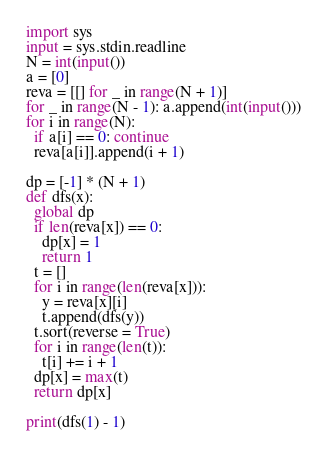Convert code to text. <code><loc_0><loc_0><loc_500><loc_500><_Python_>import sys
input = sys.stdin.readline
N = int(input())
a = [0]
reva = [[] for _ in range(N + 1)]
for _ in range(N - 1): a.append(int(input()))
for i in range(N):
  if a[i] == 0: continue
  reva[a[i]].append(i + 1)

dp = [-1] * (N + 1)
def dfs(x):
  global dp
  if len(reva[x]) == 0:
    dp[x] = 1
    return 1
  t = []
  for i in range(len(reva[x])):
    y = reva[x][i]
    t.append(dfs(y))
  t.sort(reverse = True)
  for i in range(len(t)):
    t[i] += i + 1
  dp[x] = max(t)
  return dp[x]

print(dfs(1) - 1)</code> 